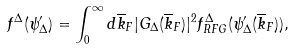<formula> <loc_0><loc_0><loc_500><loc_500>f ^ { \Delta } ( \psi ^ { \prime } _ { \Delta } ) = \int _ { 0 } ^ { \infty } d \overline { k } _ { F } | G _ { \Delta } ( \overline { k } _ { F } ) | ^ { 2 } f _ { R F G } ^ { \Delta } ( \psi _ { \Delta } ^ { \prime } ( \overline { k } _ { F } ) ) ,</formula> 